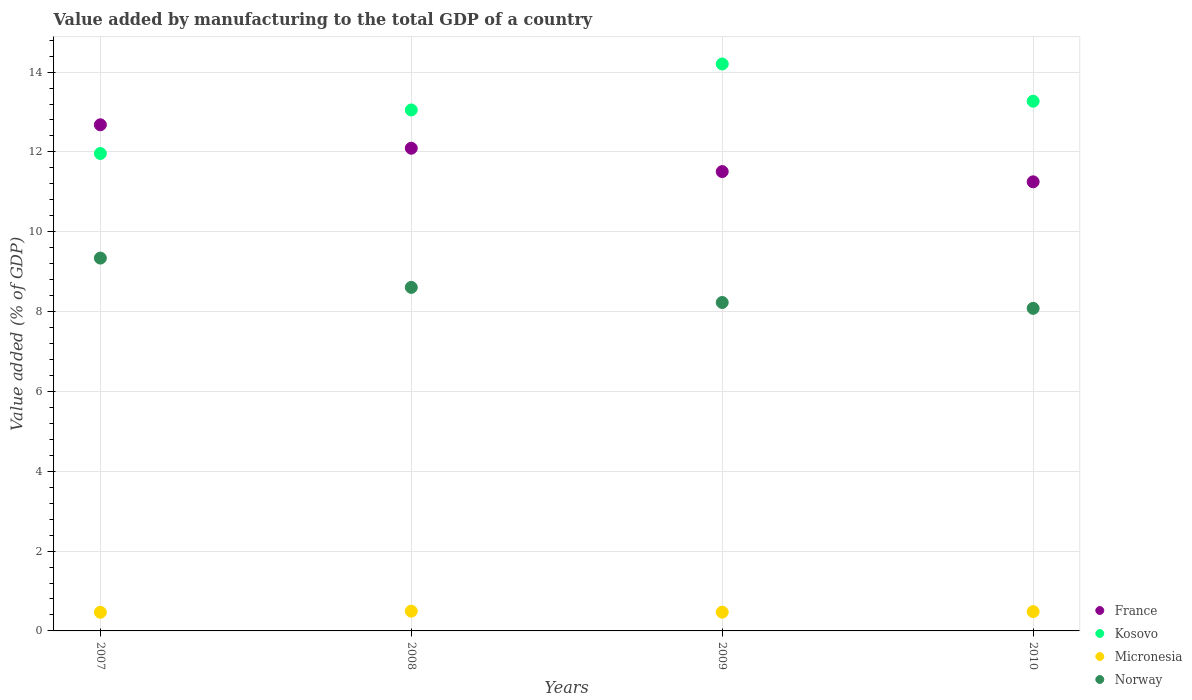Is the number of dotlines equal to the number of legend labels?
Offer a very short reply. Yes. What is the value added by manufacturing to the total GDP in France in 2010?
Offer a very short reply. 11.25. Across all years, what is the maximum value added by manufacturing to the total GDP in France?
Offer a terse response. 12.68. Across all years, what is the minimum value added by manufacturing to the total GDP in Norway?
Offer a very short reply. 8.08. In which year was the value added by manufacturing to the total GDP in France minimum?
Offer a terse response. 2010. What is the total value added by manufacturing to the total GDP in Micronesia in the graph?
Your answer should be very brief. 1.92. What is the difference between the value added by manufacturing to the total GDP in France in 2007 and that in 2009?
Make the answer very short. 1.17. What is the difference between the value added by manufacturing to the total GDP in Norway in 2007 and the value added by manufacturing to the total GDP in Micronesia in 2010?
Keep it short and to the point. 8.86. What is the average value added by manufacturing to the total GDP in France per year?
Your response must be concise. 11.88. In the year 2007, what is the difference between the value added by manufacturing to the total GDP in Kosovo and value added by manufacturing to the total GDP in France?
Provide a short and direct response. -0.72. In how many years, is the value added by manufacturing to the total GDP in Norway greater than 14 %?
Give a very brief answer. 0. What is the ratio of the value added by manufacturing to the total GDP in France in 2007 to that in 2010?
Keep it short and to the point. 1.13. What is the difference between the highest and the second highest value added by manufacturing to the total GDP in Kosovo?
Give a very brief answer. 0.93. What is the difference between the highest and the lowest value added by manufacturing to the total GDP in Norway?
Give a very brief answer. 1.26. In how many years, is the value added by manufacturing to the total GDP in Norway greater than the average value added by manufacturing to the total GDP in Norway taken over all years?
Your answer should be compact. 2. Is the sum of the value added by manufacturing to the total GDP in France in 2008 and 2010 greater than the maximum value added by manufacturing to the total GDP in Norway across all years?
Your answer should be very brief. Yes. Is the value added by manufacturing to the total GDP in Micronesia strictly less than the value added by manufacturing to the total GDP in Kosovo over the years?
Provide a succinct answer. Yes. How many dotlines are there?
Make the answer very short. 4. How many years are there in the graph?
Keep it short and to the point. 4. Does the graph contain any zero values?
Your answer should be compact. No. Does the graph contain grids?
Your answer should be very brief. Yes. How are the legend labels stacked?
Ensure brevity in your answer.  Vertical. What is the title of the graph?
Offer a terse response. Value added by manufacturing to the total GDP of a country. Does "Mauritania" appear as one of the legend labels in the graph?
Your response must be concise. No. What is the label or title of the X-axis?
Your answer should be compact. Years. What is the label or title of the Y-axis?
Offer a terse response. Value added (% of GDP). What is the Value added (% of GDP) in France in 2007?
Keep it short and to the point. 12.68. What is the Value added (% of GDP) of Kosovo in 2007?
Provide a succinct answer. 11.96. What is the Value added (% of GDP) of Micronesia in 2007?
Give a very brief answer. 0.47. What is the Value added (% of GDP) of Norway in 2007?
Ensure brevity in your answer.  9.34. What is the Value added (% of GDP) of France in 2008?
Make the answer very short. 12.09. What is the Value added (% of GDP) in Kosovo in 2008?
Make the answer very short. 13.05. What is the Value added (% of GDP) in Micronesia in 2008?
Provide a succinct answer. 0.49. What is the Value added (% of GDP) in Norway in 2008?
Offer a very short reply. 8.61. What is the Value added (% of GDP) of France in 2009?
Offer a terse response. 11.51. What is the Value added (% of GDP) in Kosovo in 2009?
Your answer should be compact. 14.2. What is the Value added (% of GDP) of Micronesia in 2009?
Your answer should be compact. 0.47. What is the Value added (% of GDP) of Norway in 2009?
Offer a terse response. 8.23. What is the Value added (% of GDP) of France in 2010?
Keep it short and to the point. 11.25. What is the Value added (% of GDP) in Kosovo in 2010?
Keep it short and to the point. 13.27. What is the Value added (% of GDP) of Micronesia in 2010?
Offer a very short reply. 0.48. What is the Value added (% of GDP) of Norway in 2010?
Give a very brief answer. 8.08. Across all years, what is the maximum Value added (% of GDP) in France?
Your answer should be compact. 12.68. Across all years, what is the maximum Value added (% of GDP) in Kosovo?
Offer a very short reply. 14.2. Across all years, what is the maximum Value added (% of GDP) of Micronesia?
Make the answer very short. 0.49. Across all years, what is the maximum Value added (% of GDP) of Norway?
Your answer should be very brief. 9.34. Across all years, what is the minimum Value added (% of GDP) in France?
Your answer should be very brief. 11.25. Across all years, what is the minimum Value added (% of GDP) of Kosovo?
Make the answer very short. 11.96. Across all years, what is the minimum Value added (% of GDP) of Micronesia?
Offer a terse response. 0.47. Across all years, what is the minimum Value added (% of GDP) of Norway?
Keep it short and to the point. 8.08. What is the total Value added (% of GDP) in France in the graph?
Provide a short and direct response. 47.53. What is the total Value added (% of GDP) in Kosovo in the graph?
Ensure brevity in your answer.  52.48. What is the total Value added (% of GDP) in Micronesia in the graph?
Make the answer very short. 1.92. What is the total Value added (% of GDP) of Norway in the graph?
Make the answer very short. 34.26. What is the difference between the Value added (% of GDP) of France in 2007 and that in 2008?
Give a very brief answer. 0.59. What is the difference between the Value added (% of GDP) in Kosovo in 2007 and that in 2008?
Ensure brevity in your answer.  -1.09. What is the difference between the Value added (% of GDP) in Micronesia in 2007 and that in 2008?
Offer a very short reply. -0.03. What is the difference between the Value added (% of GDP) in Norway in 2007 and that in 2008?
Make the answer very short. 0.73. What is the difference between the Value added (% of GDP) in France in 2007 and that in 2009?
Offer a terse response. 1.17. What is the difference between the Value added (% of GDP) of Kosovo in 2007 and that in 2009?
Your answer should be very brief. -2.24. What is the difference between the Value added (% of GDP) of Micronesia in 2007 and that in 2009?
Provide a short and direct response. -0. What is the difference between the Value added (% of GDP) in Norway in 2007 and that in 2009?
Your answer should be compact. 1.11. What is the difference between the Value added (% of GDP) in France in 2007 and that in 2010?
Your response must be concise. 1.43. What is the difference between the Value added (% of GDP) of Kosovo in 2007 and that in 2010?
Provide a short and direct response. -1.31. What is the difference between the Value added (% of GDP) of Micronesia in 2007 and that in 2010?
Your response must be concise. -0.02. What is the difference between the Value added (% of GDP) of Norway in 2007 and that in 2010?
Make the answer very short. 1.26. What is the difference between the Value added (% of GDP) in France in 2008 and that in 2009?
Ensure brevity in your answer.  0.58. What is the difference between the Value added (% of GDP) in Kosovo in 2008 and that in 2009?
Provide a short and direct response. -1.15. What is the difference between the Value added (% of GDP) in Micronesia in 2008 and that in 2009?
Your answer should be very brief. 0.03. What is the difference between the Value added (% of GDP) in Norway in 2008 and that in 2009?
Offer a very short reply. 0.38. What is the difference between the Value added (% of GDP) in France in 2008 and that in 2010?
Your answer should be compact. 0.84. What is the difference between the Value added (% of GDP) of Kosovo in 2008 and that in 2010?
Keep it short and to the point. -0.22. What is the difference between the Value added (% of GDP) of Micronesia in 2008 and that in 2010?
Make the answer very short. 0.01. What is the difference between the Value added (% of GDP) in Norway in 2008 and that in 2010?
Offer a very short reply. 0.53. What is the difference between the Value added (% of GDP) in France in 2009 and that in 2010?
Give a very brief answer. 0.26. What is the difference between the Value added (% of GDP) of Kosovo in 2009 and that in 2010?
Offer a very short reply. 0.93. What is the difference between the Value added (% of GDP) in Micronesia in 2009 and that in 2010?
Offer a very short reply. -0.01. What is the difference between the Value added (% of GDP) in Norway in 2009 and that in 2010?
Ensure brevity in your answer.  0.15. What is the difference between the Value added (% of GDP) in France in 2007 and the Value added (% of GDP) in Kosovo in 2008?
Offer a very short reply. -0.37. What is the difference between the Value added (% of GDP) in France in 2007 and the Value added (% of GDP) in Micronesia in 2008?
Your answer should be compact. 12.18. What is the difference between the Value added (% of GDP) of France in 2007 and the Value added (% of GDP) of Norway in 2008?
Provide a succinct answer. 4.07. What is the difference between the Value added (% of GDP) of Kosovo in 2007 and the Value added (% of GDP) of Micronesia in 2008?
Provide a succinct answer. 11.47. What is the difference between the Value added (% of GDP) of Kosovo in 2007 and the Value added (% of GDP) of Norway in 2008?
Keep it short and to the point. 3.35. What is the difference between the Value added (% of GDP) in Micronesia in 2007 and the Value added (% of GDP) in Norway in 2008?
Offer a terse response. -8.14. What is the difference between the Value added (% of GDP) in France in 2007 and the Value added (% of GDP) in Kosovo in 2009?
Your answer should be compact. -1.52. What is the difference between the Value added (% of GDP) in France in 2007 and the Value added (% of GDP) in Micronesia in 2009?
Make the answer very short. 12.21. What is the difference between the Value added (% of GDP) of France in 2007 and the Value added (% of GDP) of Norway in 2009?
Offer a terse response. 4.45. What is the difference between the Value added (% of GDP) in Kosovo in 2007 and the Value added (% of GDP) in Micronesia in 2009?
Provide a succinct answer. 11.49. What is the difference between the Value added (% of GDP) of Kosovo in 2007 and the Value added (% of GDP) of Norway in 2009?
Make the answer very short. 3.73. What is the difference between the Value added (% of GDP) in Micronesia in 2007 and the Value added (% of GDP) in Norway in 2009?
Ensure brevity in your answer.  -7.76. What is the difference between the Value added (% of GDP) of France in 2007 and the Value added (% of GDP) of Kosovo in 2010?
Keep it short and to the point. -0.59. What is the difference between the Value added (% of GDP) in France in 2007 and the Value added (% of GDP) in Micronesia in 2010?
Ensure brevity in your answer.  12.2. What is the difference between the Value added (% of GDP) in France in 2007 and the Value added (% of GDP) in Norway in 2010?
Ensure brevity in your answer.  4.6. What is the difference between the Value added (% of GDP) in Kosovo in 2007 and the Value added (% of GDP) in Micronesia in 2010?
Ensure brevity in your answer.  11.48. What is the difference between the Value added (% of GDP) of Kosovo in 2007 and the Value added (% of GDP) of Norway in 2010?
Offer a terse response. 3.88. What is the difference between the Value added (% of GDP) in Micronesia in 2007 and the Value added (% of GDP) in Norway in 2010?
Your answer should be very brief. -7.61. What is the difference between the Value added (% of GDP) in France in 2008 and the Value added (% of GDP) in Kosovo in 2009?
Offer a very short reply. -2.11. What is the difference between the Value added (% of GDP) in France in 2008 and the Value added (% of GDP) in Micronesia in 2009?
Give a very brief answer. 11.62. What is the difference between the Value added (% of GDP) of France in 2008 and the Value added (% of GDP) of Norway in 2009?
Keep it short and to the point. 3.86. What is the difference between the Value added (% of GDP) of Kosovo in 2008 and the Value added (% of GDP) of Micronesia in 2009?
Your answer should be very brief. 12.58. What is the difference between the Value added (% of GDP) in Kosovo in 2008 and the Value added (% of GDP) in Norway in 2009?
Your response must be concise. 4.82. What is the difference between the Value added (% of GDP) in Micronesia in 2008 and the Value added (% of GDP) in Norway in 2009?
Keep it short and to the point. -7.73. What is the difference between the Value added (% of GDP) in France in 2008 and the Value added (% of GDP) in Kosovo in 2010?
Ensure brevity in your answer.  -1.18. What is the difference between the Value added (% of GDP) of France in 2008 and the Value added (% of GDP) of Micronesia in 2010?
Keep it short and to the point. 11.61. What is the difference between the Value added (% of GDP) in France in 2008 and the Value added (% of GDP) in Norway in 2010?
Your answer should be compact. 4.01. What is the difference between the Value added (% of GDP) in Kosovo in 2008 and the Value added (% of GDP) in Micronesia in 2010?
Give a very brief answer. 12.57. What is the difference between the Value added (% of GDP) in Kosovo in 2008 and the Value added (% of GDP) in Norway in 2010?
Make the answer very short. 4.97. What is the difference between the Value added (% of GDP) of Micronesia in 2008 and the Value added (% of GDP) of Norway in 2010?
Make the answer very short. -7.59. What is the difference between the Value added (% of GDP) of France in 2009 and the Value added (% of GDP) of Kosovo in 2010?
Your response must be concise. -1.76. What is the difference between the Value added (% of GDP) of France in 2009 and the Value added (% of GDP) of Micronesia in 2010?
Provide a short and direct response. 11.02. What is the difference between the Value added (% of GDP) in France in 2009 and the Value added (% of GDP) in Norway in 2010?
Make the answer very short. 3.43. What is the difference between the Value added (% of GDP) of Kosovo in 2009 and the Value added (% of GDP) of Micronesia in 2010?
Your response must be concise. 13.72. What is the difference between the Value added (% of GDP) in Kosovo in 2009 and the Value added (% of GDP) in Norway in 2010?
Make the answer very short. 6.12. What is the difference between the Value added (% of GDP) in Micronesia in 2009 and the Value added (% of GDP) in Norway in 2010?
Provide a succinct answer. -7.61. What is the average Value added (% of GDP) in France per year?
Give a very brief answer. 11.88. What is the average Value added (% of GDP) in Kosovo per year?
Provide a succinct answer. 13.12. What is the average Value added (% of GDP) in Micronesia per year?
Provide a short and direct response. 0.48. What is the average Value added (% of GDP) in Norway per year?
Make the answer very short. 8.56. In the year 2007, what is the difference between the Value added (% of GDP) in France and Value added (% of GDP) in Kosovo?
Make the answer very short. 0.72. In the year 2007, what is the difference between the Value added (% of GDP) in France and Value added (% of GDP) in Micronesia?
Offer a very short reply. 12.21. In the year 2007, what is the difference between the Value added (% of GDP) in France and Value added (% of GDP) in Norway?
Your answer should be very brief. 3.34. In the year 2007, what is the difference between the Value added (% of GDP) in Kosovo and Value added (% of GDP) in Micronesia?
Make the answer very short. 11.49. In the year 2007, what is the difference between the Value added (% of GDP) in Kosovo and Value added (% of GDP) in Norway?
Ensure brevity in your answer.  2.62. In the year 2007, what is the difference between the Value added (% of GDP) in Micronesia and Value added (% of GDP) in Norway?
Give a very brief answer. -8.87. In the year 2008, what is the difference between the Value added (% of GDP) of France and Value added (% of GDP) of Kosovo?
Your response must be concise. -0.96. In the year 2008, what is the difference between the Value added (% of GDP) of France and Value added (% of GDP) of Micronesia?
Ensure brevity in your answer.  11.6. In the year 2008, what is the difference between the Value added (% of GDP) of France and Value added (% of GDP) of Norway?
Offer a very short reply. 3.49. In the year 2008, what is the difference between the Value added (% of GDP) in Kosovo and Value added (% of GDP) in Micronesia?
Offer a terse response. 12.56. In the year 2008, what is the difference between the Value added (% of GDP) of Kosovo and Value added (% of GDP) of Norway?
Make the answer very short. 4.44. In the year 2008, what is the difference between the Value added (% of GDP) in Micronesia and Value added (% of GDP) in Norway?
Provide a succinct answer. -8.11. In the year 2009, what is the difference between the Value added (% of GDP) in France and Value added (% of GDP) in Kosovo?
Provide a succinct answer. -2.7. In the year 2009, what is the difference between the Value added (% of GDP) in France and Value added (% of GDP) in Micronesia?
Your answer should be very brief. 11.04. In the year 2009, what is the difference between the Value added (% of GDP) of France and Value added (% of GDP) of Norway?
Make the answer very short. 3.28. In the year 2009, what is the difference between the Value added (% of GDP) of Kosovo and Value added (% of GDP) of Micronesia?
Offer a very short reply. 13.73. In the year 2009, what is the difference between the Value added (% of GDP) in Kosovo and Value added (% of GDP) in Norway?
Keep it short and to the point. 5.97. In the year 2009, what is the difference between the Value added (% of GDP) in Micronesia and Value added (% of GDP) in Norway?
Give a very brief answer. -7.76. In the year 2010, what is the difference between the Value added (% of GDP) of France and Value added (% of GDP) of Kosovo?
Your response must be concise. -2.02. In the year 2010, what is the difference between the Value added (% of GDP) of France and Value added (% of GDP) of Micronesia?
Your answer should be very brief. 10.77. In the year 2010, what is the difference between the Value added (% of GDP) of France and Value added (% of GDP) of Norway?
Ensure brevity in your answer.  3.17. In the year 2010, what is the difference between the Value added (% of GDP) of Kosovo and Value added (% of GDP) of Micronesia?
Give a very brief answer. 12.79. In the year 2010, what is the difference between the Value added (% of GDP) of Kosovo and Value added (% of GDP) of Norway?
Ensure brevity in your answer.  5.19. In the year 2010, what is the difference between the Value added (% of GDP) of Micronesia and Value added (% of GDP) of Norway?
Keep it short and to the point. -7.6. What is the ratio of the Value added (% of GDP) of France in 2007 to that in 2008?
Provide a succinct answer. 1.05. What is the ratio of the Value added (% of GDP) of Kosovo in 2007 to that in 2008?
Offer a terse response. 0.92. What is the ratio of the Value added (% of GDP) in Micronesia in 2007 to that in 2008?
Provide a short and direct response. 0.94. What is the ratio of the Value added (% of GDP) of Norway in 2007 to that in 2008?
Provide a short and direct response. 1.09. What is the ratio of the Value added (% of GDP) in France in 2007 to that in 2009?
Your answer should be compact. 1.1. What is the ratio of the Value added (% of GDP) of Kosovo in 2007 to that in 2009?
Offer a very short reply. 0.84. What is the ratio of the Value added (% of GDP) in Micronesia in 2007 to that in 2009?
Provide a short and direct response. 0.99. What is the ratio of the Value added (% of GDP) of Norway in 2007 to that in 2009?
Ensure brevity in your answer.  1.14. What is the ratio of the Value added (% of GDP) of France in 2007 to that in 2010?
Offer a terse response. 1.13. What is the ratio of the Value added (% of GDP) of Kosovo in 2007 to that in 2010?
Provide a short and direct response. 0.9. What is the ratio of the Value added (% of GDP) in Micronesia in 2007 to that in 2010?
Ensure brevity in your answer.  0.97. What is the ratio of the Value added (% of GDP) in Norway in 2007 to that in 2010?
Make the answer very short. 1.16. What is the ratio of the Value added (% of GDP) in France in 2008 to that in 2009?
Give a very brief answer. 1.05. What is the ratio of the Value added (% of GDP) of Kosovo in 2008 to that in 2009?
Make the answer very short. 0.92. What is the ratio of the Value added (% of GDP) of Micronesia in 2008 to that in 2009?
Ensure brevity in your answer.  1.05. What is the ratio of the Value added (% of GDP) in Norway in 2008 to that in 2009?
Your answer should be very brief. 1.05. What is the ratio of the Value added (% of GDP) in France in 2008 to that in 2010?
Your answer should be compact. 1.07. What is the ratio of the Value added (% of GDP) in Kosovo in 2008 to that in 2010?
Provide a short and direct response. 0.98. What is the ratio of the Value added (% of GDP) in Micronesia in 2008 to that in 2010?
Make the answer very short. 1.02. What is the ratio of the Value added (% of GDP) in Norway in 2008 to that in 2010?
Give a very brief answer. 1.06. What is the ratio of the Value added (% of GDP) in France in 2009 to that in 2010?
Provide a short and direct response. 1.02. What is the ratio of the Value added (% of GDP) of Kosovo in 2009 to that in 2010?
Ensure brevity in your answer.  1.07. What is the ratio of the Value added (% of GDP) of Micronesia in 2009 to that in 2010?
Your response must be concise. 0.97. What is the ratio of the Value added (% of GDP) in Norway in 2009 to that in 2010?
Give a very brief answer. 1.02. What is the difference between the highest and the second highest Value added (% of GDP) of France?
Your response must be concise. 0.59. What is the difference between the highest and the second highest Value added (% of GDP) in Kosovo?
Ensure brevity in your answer.  0.93. What is the difference between the highest and the second highest Value added (% of GDP) in Micronesia?
Your answer should be compact. 0.01. What is the difference between the highest and the second highest Value added (% of GDP) of Norway?
Provide a short and direct response. 0.73. What is the difference between the highest and the lowest Value added (% of GDP) in France?
Your response must be concise. 1.43. What is the difference between the highest and the lowest Value added (% of GDP) of Kosovo?
Provide a short and direct response. 2.24. What is the difference between the highest and the lowest Value added (% of GDP) of Micronesia?
Give a very brief answer. 0.03. What is the difference between the highest and the lowest Value added (% of GDP) of Norway?
Keep it short and to the point. 1.26. 